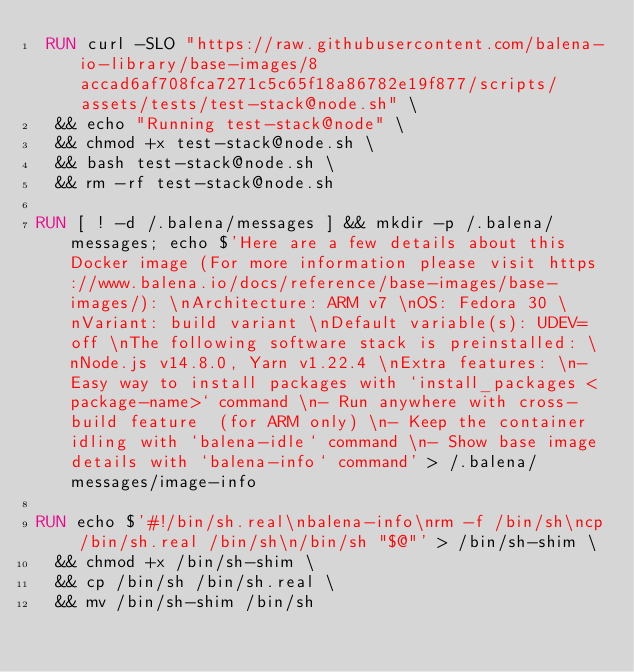<code> <loc_0><loc_0><loc_500><loc_500><_Dockerfile_> RUN curl -SLO "https://raw.githubusercontent.com/balena-io-library/base-images/8accad6af708fca7271c5c65f18a86782e19f877/scripts/assets/tests/test-stack@node.sh" \
  && echo "Running test-stack@node" \
  && chmod +x test-stack@node.sh \
  && bash test-stack@node.sh \
  && rm -rf test-stack@node.sh 

RUN [ ! -d /.balena/messages ] && mkdir -p /.balena/messages; echo $'Here are a few details about this Docker image (For more information please visit https://www.balena.io/docs/reference/base-images/base-images/): \nArchitecture: ARM v7 \nOS: Fedora 30 \nVariant: build variant \nDefault variable(s): UDEV=off \nThe following software stack is preinstalled: \nNode.js v14.8.0, Yarn v1.22.4 \nExtra features: \n- Easy way to install packages with `install_packages <package-name>` command \n- Run anywhere with cross-build feature  (for ARM only) \n- Keep the container idling with `balena-idle` command \n- Show base image details with `balena-info` command' > /.balena/messages/image-info

RUN echo $'#!/bin/sh.real\nbalena-info\nrm -f /bin/sh\ncp /bin/sh.real /bin/sh\n/bin/sh "$@"' > /bin/sh-shim \
	&& chmod +x /bin/sh-shim \
	&& cp /bin/sh /bin/sh.real \
	&& mv /bin/sh-shim /bin/sh</code> 